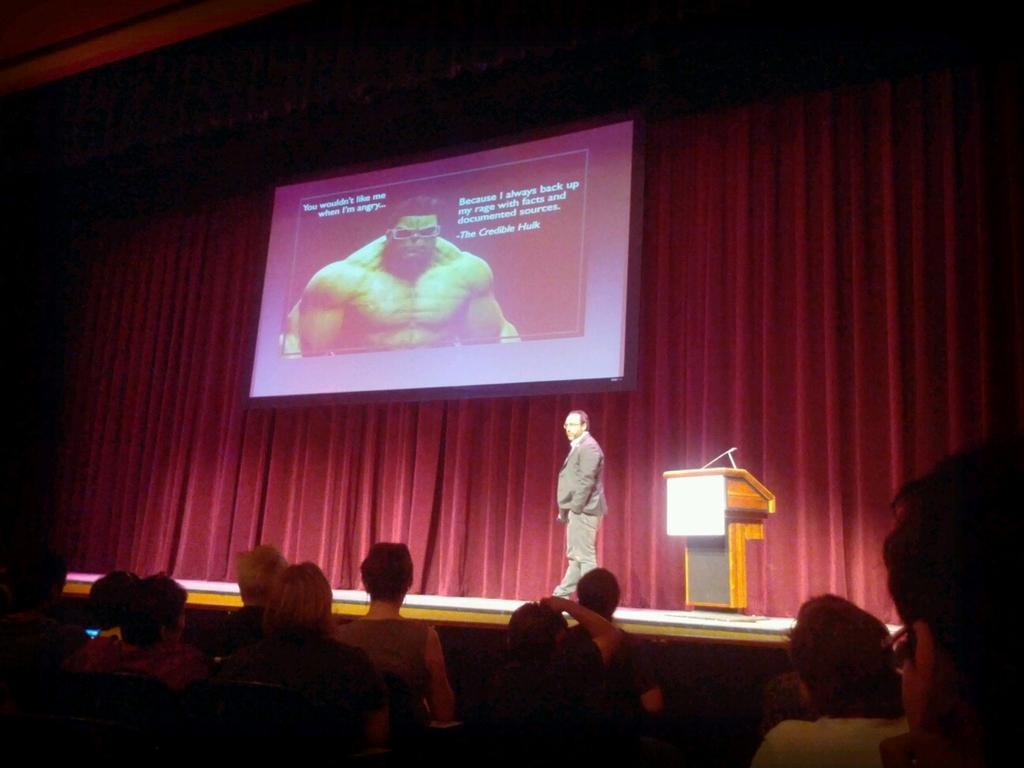Could you give a brief overview of what you see in this image? This picture is clicked in the concert hall. The man in the middle of the picture is standing. I think he is holding a microphone. Behind him, we see a podium on which microphone is placed. At the bottom of the picture, we see many people are sitting on the chairs. In the background, we see a projector screen which is displaying something. Behind that, we see a sheet in maroon color. 